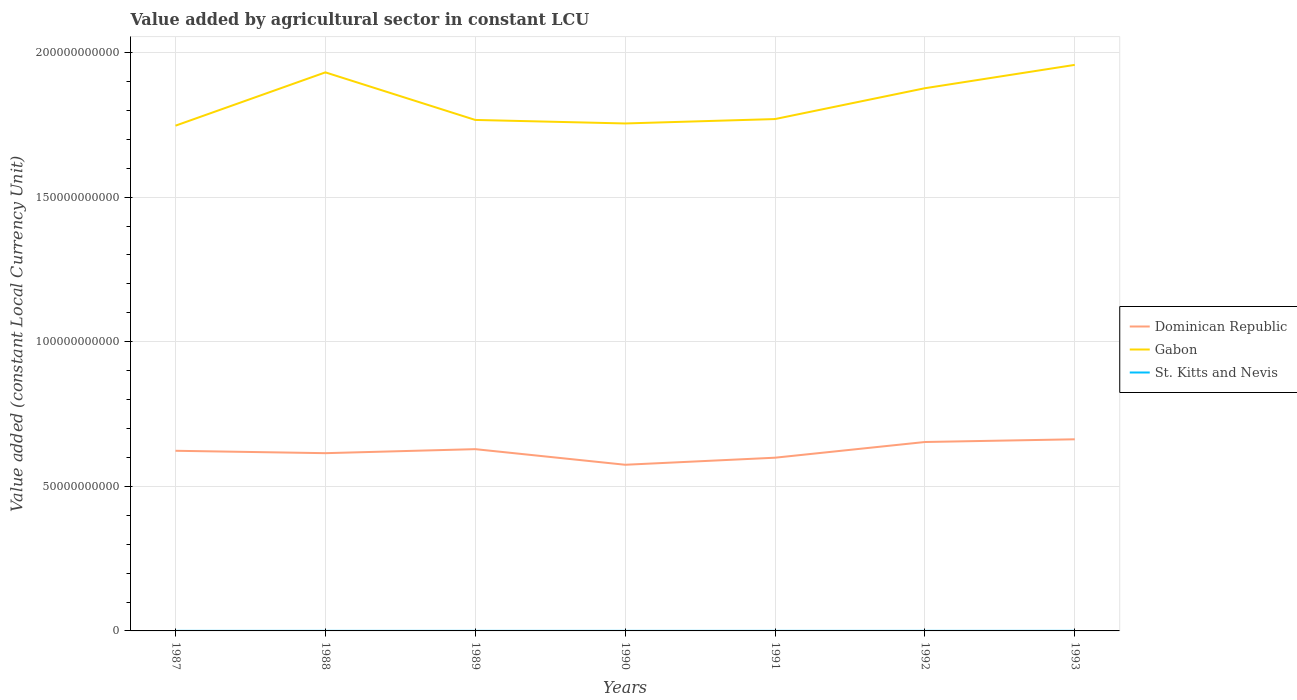Across all years, what is the maximum value added by agricultural sector in St. Kitts and Nevis?
Give a very brief answer. 2.16e+07. In which year was the value added by agricultural sector in Gabon maximum?
Make the answer very short. 1987. What is the total value added by agricultural sector in Gabon in the graph?
Ensure brevity in your answer.  -2.03e+1. What is the difference between the highest and the second highest value added by agricultural sector in Gabon?
Offer a very short reply. 2.10e+1. Is the value added by agricultural sector in Dominican Republic strictly greater than the value added by agricultural sector in Gabon over the years?
Provide a short and direct response. Yes. How many lines are there?
Offer a very short reply. 3. How many years are there in the graph?
Ensure brevity in your answer.  7. What is the difference between two consecutive major ticks on the Y-axis?
Offer a terse response. 5.00e+1. Does the graph contain any zero values?
Make the answer very short. No. Does the graph contain grids?
Your response must be concise. Yes. Where does the legend appear in the graph?
Provide a succinct answer. Center right. How many legend labels are there?
Offer a very short reply. 3. What is the title of the graph?
Offer a very short reply. Value added by agricultural sector in constant LCU. Does "Singapore" appear as one of the legend labels in the graph?
Your response must be concise. No. What is the label or title of the Y-axis?
Provide a succinct answer. Value added (constant Local Currency Unit). What is the Value added (constant Local Currency Unit) of Dominican Republic in 1987?
Your answer should be very brief. 6.23e+1. What is the Value added (constant Local Currency Unit) of Gabon in 1987?
Your answer should be compact. 1.75e+11. What is the Value added (constant Local Currency Unit) of St. Kitts and Nevis in 1987?
Provide a succinct answer. 2.18e+07. What is the Value added (constant Local Currency Unit) of Dominican Republic in 1988?
Make the answer very short. 6.15e+1. What is the Value added (constant Local Currency Unit) in Gabon in 1988?
Your answer should be very brief. 1.93e+11. What is the Value added (constant Local Currency Unit) in St. Kitts and Nevis in 1988?
Make the answer very short. 2.29e+07. What is the Value added (constant Local Currency Unit) in Dominican Republic in 1989?
Provide a succinct answer. 6.28e+1. What is the Value added (constant Local Currency Unit) in Gabon in 1989?
Your answer should be compact. 1.77e+11. What is the Value added (constant Local Currency Unit) of St. Kitts and Nevis in 1989?
Ensure brevity in your answer.  2.21e+07. What is the Value added (constant Local Currency Unit) of Dominican Republic in 1990?
Ensure brevity in your answer.  5.75e+1. What is the Value added (constant Local Currency Unit) of Gabon in 1990?
Your response must be concise. 1.75e+11. What is the Value added (constant Local Currency Unit) in St. Kitts and Nevis in 1990?
Give a very brief answer. 2.16e+07. What is the Value added (constant Local Currency Unit) in Dominican Republic in 1991?
Keep it short and to the point. 5.99e+1. What is the Value added (constant Local Currency Unit) in Gabon in 1991?
Your answer should be very brief. 1.77e+11. What is the Value added (constant Local Currency Unit) of St. Kitts and Nevis in 1991?
Keep it short and to the point. 2.28e+07. What is the Value added (constant Local Currency Unit) in Dominican Republic in 1992?
Your answer should be compact. 6.53e+1. What is the Value added (constant Local Currency Unit) of Gabon in 1992?
Your answer should be very brief. 1.88e+11. What is the Value added (constant Local Currency Unit) in St. Kitts and Nevis in 1992?
Offer a very short reply. 2.39e+07. What is the Value added (constant Local Currency Unit) of Dominican Republic in 1993?
Offer a very short reply. 6.63e+1. What is the Value added (constant Local Currency Unit) of Gabon in 1993?
Give a very brief answer. 1.96e+11. What is the Value added (constant Local Currency Unit) in St. Kitts and Nevis in 1993?
Your answer should be very brief. 2.47e+07. Across all years, what is the maximum Value added (constant Local Currency Unit) of Dominican Republic?
Offer a very short reply. 6.63e+1. Across all years, what is the maximum Value added (constant Local Currency Unit) of Gabon?
Ensure brevity in your answer.  1.96e+11. Across all years, what is the maximum Value added (constant Local Currency Unit) in St. Kitts and Nevis?
Provide a succinct answer. 2.47e+07. Across all years, what is the minimum Value added (constant Local Currency Unit) in Dominican Republic?
Keep it short and to the point. 5.75e+1. Across all years, what is the minimum Value added (constant Local Currency Unit) in Gabon?
Your answer should be compact. 1.75e+11. Across all years, what is the minimum Value added (constant Local Currency Unit) of St. Kitts and Nevis?
Make the answer very short. 2.16e+07. What is the total Value added (constant Local Currency Unit) in Dominican Republic in the graph?
Offer a terse response. 4.36e+11. What is the total Value added (constant Local Currency Unit) of Gabon in the graph?
Ensure brevity in your answer.  1.28e+12. What is the total Value added (constant Local Currency Unit) in St. Kitts and Nevis in the graph?
Provide a succinct answer. 1.60e+08. What is the difference between the Value added (constant Local Currency Unit) in Dominican Republic in 1987 and that in 1988?
Offer a very short reply. 8.25e+08. What is the difference between the Value added (constant Local Currency Unit) of Gabon in 1987 and that in 1988?
Offer a very short reply. -1.84e+1. What is the difference between the Value added (constant Local Currency Unit) in St. Kitts and Nevis in 1987 and that in 1988?
Offer a terse response. -1.15e+06. What is the difference between the Value added (constant Local Currency Unit) in Dominican Republic in 1987 and that in 1989?
Make the answer very short. -5.61e+08. What is the difference between the Value added (constant Local Currency Unit) of Gabon in 1987 and that in 1989?
Your answer should be very brief. -1.98e+09. What is the difference between the Value added (constant Local Currency Unit) in St. Kitts and Nevis in 1987 and that in 1989?
Provide a succinct answer. -3.05e+05. What is the difference between the Value added (constant Local Currency Unit) in Dominican Republic in 1987 and that in 1990?
Provide a short and direct response. 4.83e+09. What is the difference between the Value added (constant Local Currency Unit) in Gabon in 1987 and that in 1990?
Provide a short and direct response. -7.62e+08. What is the difference between the Value added (constant Local Currency Unit) in St. Kitts and Nevis in 1987 and that in 1990?
Provide a succinct answer. 2.00e+05. What is the difference between the Value added (constant Local Currency Unit) of Dominican Republic in 1987 and that in 1991?
Provide a short and direct response. 2.39e+09. What is the difference between the Value added (constant Local Currency Unit) in Gabon in 1987 and that in 1991?
Offer a very short reply. -2.28e+09. What is the difference between the Value added (constant Local Currency Unit) of St. Kitts and Nevis in 1987 and that in 1991?
Provide a succinct answer. -1.04e+06. What is the difference between the Value added (constant Local Currency Unit) in Dominican Republic in 1987 and that in 1992?
Your response must be concise. -3.03e+09. What is the difference between the Value added (constant Local Currency Unit) in Gabon in 1987 and that in 1992?
Your response must be concise. -1.29e+1. What is the difference between the Value added (constant Local Currency Unit) of St. Kitts and Nevis in 1987 and that in 1992?
Provide a succinct answer. -2.09e+06. What is the difference between the Value added (constant Local Currency Unit) of Dominican Republic in 1987 and that in 1993?
Provide a succinct answer. -3.97e+09. What is the difference between the Value added (constant Local Currency Unit) in Gabon in 1987 and that in 1993?
Your answer should be very brief. -2.10e+1. What is the difference between the Value added (constant Local Currency Unit) in St. Kitts and Nevis in 1987 and that in 1993?
Provide a succinct answer. -2.87e+06. What is the difference between the Value added (constant Local Currency Unit) in Dominican Republic in 1988 and that in 1989?
Keep it short and to the point. -1.39e+09. What is the difference between the Value added (constant Local Currency Unit) in Gabon in 1988 and that in 1989?
Your answer should be compact. 1.65e+1. What is the difference between the Value added (constant Local Currency Unit) in St. Kitts and Nevis in 1988 and that in 1989?
Give a very brief answer. 8.42e+05. What is the difference between the Value added (constant Local Currency Unit) of Dominican Republic in 1988 and that in 1990?
Provide a succinct answer. 4.01e+09. What is the difference between the Value added (constant Local Currency Unit) in Gabon in 1988 and that in 1990?
Your answer should be very brief. 1.77e+1. What is the difference between the Value added (constant Local Currency Unit) of St. Kitts and Nevis in 1988 and that in 1990?
Offer a terse response. 1.35e+06. What is the difference between the Value added (constant Local Currency Unit) of Dominican Republic in 1988 and that in 1991?
Offer a very short reply. 1.57e+09. What is the difference between the Value added (constant Local Currency Unit) in Gabon in 1988 and that in 1991?
Give a very brief answer. 1.61e+1. What is the difference between the Value added (constant Local Currency Unit) of St. Kitts and Nevis in 1988 and that in 1991?
Offer a terse response. 1.11e+05. What is the difference between the Value added (constant Local Currency Unit) of Dominican Republic in 1988 and that in 1992?
Keep it short and to the point. -3.86e+09. What is the difference between the Value added (constant Local Currency Unit) in Gabon in 1988 and that in 1992?
Give a very brief answer. 5.48e+09. What is the difference between the Value added (constant Local Currency Unit) of St. Kitts and Nevis in 1988 and that in 1992?
Make the answer very short. -9.39e+05. What is the difference between the Value added (constant Local Currency Unit) of Dominican Republic in 1988 and that in 1993?
Your answer should be very brief. -4.80e+09. What is the difference between the Value added (constant Local Currency Unit) of Gabon in 1988 and that in 1993?
Your response must be concise. -2.59e+09. What is the difference between the Value added (constant Local Currency Unit) in St. Kitts and Nevis in 1988 and that in 1993?
Make the answer very short. -1.72e+06. What is the difference between the Value added (constant Local Currency Unit) in Dominican Republic in 1989 and that in 1990?
Provide a short and direct response. 5.39e+09. What is the difference between the Value added (constant Local Currency Unit) in Gabon in 1989 and that in 1990?
Ensure brevity in your answer.  1.22e+09. What is the difference between the Value added (constant Local Currency Unit) of St. Kitts and Nevis in 1989 and that in 1990?
Your answer should be very brief. 5.05e+05. What is the difference between the Value added (constant Local Currency Unit) in Dominican Republic in 1989 and that in 1991?
Offer a very short reply. 2.96e+09. What is the difference between the Value added (constant Local Currency Unit) of Gabon in 1989 and that in 1991?
Keep it short and to the point. -3.05e+08. What is the difference between the Value added (constant Local Currency Unit) in St. Kitts and Nevis in 1989 and that in 1991?
Offer a terse response. -7.32e+05. What is the difference between the Value added (constant Local Currency Unit) in Dominican Republic in 1989 and that in 1992?
Your answer should be compact. -2.47e+09. What is the difference between the Value added (constant Local Currency Unit) in Gabon in 1989 and that in 1992?
Your answer should be very brief. -1.10e+1. What is the difference between the Value added (constant Local Currency Unit) in St. Kitts and Nevis in 1989 and that in 1992?
Provide a short and direct response. -1.78e+06. What is the difference between the Value added (constant Local Currency Unit) of Dominican Republic in 1989 and that in 1993?
Your answer should be very brief. -3.41e+09. What is the difference between the Value added (constant Local Currency Unit) of Gabon in 1989 and that in 1993?
Your answer should be very brief. -1.90e+1. What is the difference between the Value added (constant Local Currency Unit) in St. Kitts and Nevis in 1989 and that in 1993?
Keep it short and to the point. -2.57e+06. What is the difference between the Value added (constant Local Currency Unit) in Dominican Republic in 1990 and that in 1991?
Give a very brief answer. -2.44e+09. What is the difference between the Value added (constant Local Currency Unit) of Gabon in 1990 and that in 1991?
Provide a succinct answer. -1.52e+09. What is the difference between the Value added (constant Local Currency Unit) in St. Kitts and Nevis in 1990 and that in 1991?
Offer a terse response. -1.24e+06. What is the difference between the Value added (constant Local Currency Unit) in Dominican Republic in 1990 and that in 1992?
Provide a succinct answer. -7.87e+09. What is the difference between the Value added (constant Local Currency Unit) in Gabon in 1990 and that in 1992?
Provide a short and direct response. -1.22e+1. What is the difference between the Value added (constant Local Currency Unit) in St. Kitts and Nevis in 1990 and that in 1992?
Make the answer very short. -2.29e+06. What is the difference between the Value added (constant Local Currency Unit) in Dominican Republic in 1990 and that in 1993?
Make the answer very short. -8.80e+09. What is the difference between the Value added (constant Local Currency Unit) of Gabon in 1990 and that in 1993?
Keep it short and to the point. -2.03e+1. What is the difference between the Value added (constant Local Currency Unit) in St. Kitts and Nevis in 1990 and that in 1993?
Give a very brief answer. -3.07e+06. What is the difference between the Value added (constant Local Currency Unit) of Dominican Republic in 1991 and that in 1992?
Keep it short and to the point. -5.43e+09. What is the difference between the Value added (constant Local Currency Unit) in Gabon in 1991 and that in 1992?
Your answer should be very brief. -1.07e+1. What is the difference between the Value added (constant Local Currency Unit) in St. Kitts and Nevis in 1991 and that in 1992?
Your response must be concise. -1.05e+06. What is the difference between the Value added (constant Local Currency Unit) of Dominican Republic in 1991 and that in 1993?
Offer a very short reply. -6.37e+09. What is the difference between the Value added (constant Local Currency Unit) of Gabon in 1991 and that in 1993?
Your answer should be very brief. -1.87e+1. What is the difference between the Value added (constant Local Currency Unit) of St. Kitts and Nevis in 1991 and that in 1993?
Offer a terse response. -1.83e+06. What is the difference between the Value added (constant Local Currency Unit) in Dominican Republic in 1992 and that in 1993?
Your answer should be very brief. -9.37e+08. What is the difference between the Value added (constant Local Currency Unit) in Gabon in 1992 and that in 1993?
Your response must be concise. -8.07e+09. What is the difference between the Value added (constant Local Currency Unit) of St. Kitts and Nevis in 1992 and that in 1993?
Your response must be concise. -7.85e+05. What is the difference between the Value added (constant Local Currency Unit) in Dominican Republic in 1987 and the Value added (constant Local Currency Unit) in Gabon in 1988?
Ensure brevity in your answer.  -1.31e+11. What is the difference between the Value added (constant Local Currency Unit) in Dominican Republic in 1987 and the Value added (constant Local Currency Unit) in St. Kitts and Nevis in 1988?
Your response must be concise. 6.23e+1. What is the difference between the Value added (constant Local Currency Unit) of Gabon in 1987 and the Value added (constant Local Currency Unit) of St. Kitts and Nevis in 1988?
Your answer should be compact. 1.75e+11. What is the difference between the Value added (constant Local Currency Unit) of Dominican Republic in 1987 and the Value added (constant Local Currency Unit) of Gabon in 1989?
Keep it short and to the point. -1.14e+11. What is the difference between the Value added (constant Local Currency Unit) of Dominican Republic in 1987 and the Value added (constant Local Currency Unit) of St. Kitts and Nevis in 1989?
Your response must be concise. 6.23e+1. What is the difference between the Value added (constant Local Currency Unit) of Gabon in 1987 and the Value added (constant Local Currency Unit) of St. Kitts and Nevis in 1989?
Your response must be concise. 1.75e+11. What is the difference between the Value added (constant Local Currency Unit) of Dominican Republic in 1987 and the Value added (constant Local Currency Unit) of Gabon in 1990?
Provide a succinct answer. -1.13e+11. What is the difference between the Value added (constant Local Currency Unit) of Dominican Republic in 1987 and the Value added (constant Local Currency Unit) of St. Kitts and Nevis in 1990?
Your answer should be very brief. 6.23e+1. What is the difference between the Value added (constant Local Currency Unit) in Gabon in 1987 and the Value added (constant Local Currency Unit) in St. Kitts and Nevis in 1990?
Keep it short and to the point. 1.75e+11. What is the difference between the Value added (constant Local Currency Unit) of Dominican Republic in 1987 and the Value added (constant Local Currency Unit) of Gabon in 1991?
Offer a terse response. -1.15e+11. What is the difference between the Value added (constant Local Currency Unit) in Dominican Republic in 1987 and the Value added (constant Local Currency Unit) in St. Kitts and Nevis in 1991?
Provide a short and direct response. 6.23e+1. What is the difference between the Value added (constant Local Currency Unit) in Gabon in 1987 and the Value added (constant Local Currency Unit) in St. Kitts and Nevis in 1991?
Your answer should be compact. 1.75e+11. What is the difference between the Value added (constant Local Currency Unit) in Dominican Republic in 1987 and the Value added (constant Local Currency Unit) in Gabon in 1992?
Make the answer very short. -1.25e+11. What is the difference between the Value added (constant Local Currency Unit) of Dominican Republic in 1987 and the Value added (constant Local Currency Unit) of St. Kitts and Nevis in 1992?
Keep it short and to the point. 6.23e+1. What is the difference between the Value added (constant Local Currency Unit) in Gabon in 1987 and the Value added (constant Local Currency Unit) in St. Kitts and Nevis in 1992?
Offer a very short reply. 1.75e+11. What is the difference between the Value added (constant Local Currency Unit) in Dominican Republic in 1987 and the Value added (constant Local Currency Unit) in Gabon in 1993?
Offer a terse response. -1.33e+11. What is the difference between the Value added (constant Local Currency Unit) of Dominican Republic in 1987 and the Value added (constant Local Currency Unit) of St. Kitts and Nevis in 1993?
Give a very brief answer. 6.23e+1. What is the difference between the Value added (constant Local Currency Unit) in Gabon in 1987 and the Value added (constant Local Currency Unit) in St. Kitts and Nevis in 1993?
Offer a very short reply. 1.75e+11. What is the difference between the Value added (constant Local Currency Unit) of Dominican Republic in 1988 and the Value added (constant Local Currency Unit) of Gabon in 1989?
Provide a short and direct response. -1.15e+11. What is the difference between the Value added (constant Local Currency Unit) of Dominican Republic in 1988 and the Value added (constant Local Currency Unit) of St. Kitts and Nevis in 1989?
Offer a very short reply. 6.14e+1. What is the difference between the Value added (constant Local Currency Unit) of Gabon in 1988 and the Value added (constant Local Currency Unit) of St. Kitts and Nevis in 1989?
Your answer should be compact. 1.93e+11. What is the difference between the Value added (constant Local Currency Unit) of Dominican Republic in 1988 and the Value added (constant Local Currency Unit) of Gabon in 1990?
Offer a terse response. -1.14e+11. What is the difference between the Value added (constant Local Currency Unit) of Dominican Republic in 1988 and the Value added (constant Local Currency Unit) of St. Kitts and Nevis in 1990?
Give a very brief answer. 6.14e+1. What is the difference between the Value added (constant Local Currency Unit) in Gabon in 1988 and the Value added (constant Local Currency Unit) in St. Kitts and Nevis in 1990?
Offer a terse response. 1.93e+11. What is the difference between the Value added (constant Local Currency Unit) of Dominican Republic in 1988 and the Value added (constant Local Currency Unit) of Gabon in 1991?
Provide a short and direct response. -1.16e+11. What is the difference between the Value added (constant Local Currency Unit) in Dominican Republic in 1988 and the Value added (constant Local Currency Unit) in St. Kitts and Nevis in 1991?
Provide a short and direct response. 6.14e+1. What is the difference between the Value added (constant Local Currency Unit) of Gabon in 1988 and the Value added (constant Local Currency Unit) of St. Kitts and Nevis in 1991?
Your answer should be compact. 1.93e+11. What is the difference between the Value added (constant Local Currency Unit) of Dominican Republic in 1988 and the Value added (constant Local Currency Unit) of Gabon in 1992?
Give a very brief answer. -1.26e+11. What is the difference between the Value added (constant Local Currency Unit) in Dominican Republic in 1988 and the Value added (constant Local Currency Unit) in St. Kitts and Nevis in 1992?
Ensure brevity in your answer.  6.14e+1. What is the difference between the Value added (constant Local Currency Unit) in Gabon in 1988 and the Value added (constant Local Currency Unit) in St. Kitts and Nevis in 1992?
Give a very brief answer. 1.93e+11. What is the difference between the Value added (constant Local Currency Unit) of Dominican Republic in 1988 and the Value added (constant Local Currency Unit) of Gabon in 1993?
Provide a succinct answer. -1.34e+11. What is the difference between the Value added (constant Local Currency Unit) in Dominican Republic in 1988 and the Value added (constant Local Currency Unit) in St. Kitts and Nevis in 1993?
Provide a short and direct response. 6.14e+1. What is the difference between the Value added (constant Local Currency Unit) in Gabon in 1988 and the Value added (constant Local Currency Unit) in St. Kitts and Nevis in 1993?
Ensure brevity in your answer.  1.93e+11. What is the difference between the Value added (constant Local Currency Unit) in Dominican Republic in 1989 and the Value added (constant Local Currency Unit) in Gabon in 1990?
Offer a terse response. -1.13e+11. What is the difference between the Value added (constant Local Currency Unit) in Dominican Republic in 1989 and the Value added (constant Local Currency Unit) in St. Kitts and Nevis in 1990?
Your answer should be compact. 6.28e+1. What is the difference between the Value added (constant Local Currency Unit) in Gabon in 1989 and the Value added (constant Local Currency Unit) in St. Kitts and Nevis in 1990?
Offer a very short reply. 1.77e+11. What is the difference between the Value added (constant Local Currency Unit) of Dominican Republic in 1989 and the Value added (constant Local Currency Unit) of Gabon in 1991?
Ensure brevity in your answer.  -1.14e+11. What is the difference between the Value added (constant Local Currency Unit) in Dominican Republic in 1989 and the Value added (constant Local Currency Unit) in St. Kitts and Nevis in 1991?
Your response must be concise. 6.28e+1. What is the difference between the Value added (constant Local Currency Unit) in Gabon in 1989 and the Value added (constant Local Currency Unit) in St. Kitts and Nevis in 1991?
Your answer should be compact. 1.77e+11. What is the difference between the Value added (constant Local Currency Unit) of Dominican Republic in 1989 and the Value added (constant Local Currency Unit) of Gabon in 1992?
Provide a short and direct response. -1.25e+11. What is the difference between the Value added (constant Local Currency Unit) in Dominican Republic in 1989 and the Value added (constant Local Currency Unit) in St. Kitts and Nevis in 1992?
Offer a terse response. 6.28e+1. What is the difference between the Value added (constant Local Currency Unit) of Gabon in 1989 and the Value added (constant Local Currency Unit) of St. Kitts and Nevis in 1992?
Provide a short and direct response. 1.77e+11. What is the difference between the Value added (constant Local Currency Unit) in Dominican Republic in 1989 and the Value added (constant Local Currency Unit) in Gabon in 1993?
Your answer should be very brief. -1.33e+11. What is the difference between the Value added (constant Local Currency Unit) in Dominican Republic in 1989 and the Value added (constant Local Currency Unit) in St. Kitts and Nevis in 1993?
Your response must be concise. 6.28e+1. What is the difference between the Value added (constant Local Currency Unit) in Gabon in 1989 and the Value added (constant Local Currency Unit) in St. Kitts and Nevis in 1993?
Make the answer very short. 1.77e+11. What is the difference between the Value added (constant Local Currency Unit) of Dominican Republic in 1990 and the Value added (constant Local Currency Unit) of Gabon in 1991?
Keep it short and to the point. -1.20e+11. What is the difference between the Value added (constant Local Currency Unit) of Dominican Republic in 1990 and the Value added (constant Local Currency Unit) of St. Kitts and Nevis in 1991?
Offer a very short reply. 5.74e+1. What is the difference between the Value added (constant Local Currency Unit) of Gabon in 1990 and the Value added (constant Local Currency Unit) of St. Kitts and Nevis in 1991?
Your answer should be very brief. 1.75e+11. What is the difference between the Value added (constant Local Currency Unit) in Dominican Republic in 1990 and the Value added (constant Local Currency Unit) in Gabon in 1992?
Ensure brevity in your answer.  -1.30e+11. What is the difference between the Value added (constant Local Currency Unit) in Dominican Republic in 1990 and the Value added (constant Local Currency Unit) in St. Kitts and Nevis in 1992?
Your answer should be very brief. 5.74e+1. What is the difference between the Value added (constant Local Currency Unit) of Gabon in 1990 and the Value added (constant Local Currency Unit) of St. Kitts and Nevis in 1992?
Keep it short and to the point. 1.75e+11. What is the difference between the Value added (constant Local Currency Unit) in Dominican Republic in 1990 and the Value added (constant Local Currency Unit) in Gabon in 1993?
Make the answer very short. -1.38e+11. What is the difference between the Value added (constant Local Currency Unit) in Dominican Republic in 1990 and the Value added (constant Local Currency Unit) in St. Kitts and Nevis in 1993?
Provide a short and direct response. 5.74e+1. What is the difference between the Value added (constant Local Currency Unit) of Gabon in 1990 and the Value added (constant Local Currency Unit) of St. Kitts and Nevis in 1993?
Make the answer very short. 1.75e+11. What is the difference between the Value added (constant Local Currency Unit) of Dominican Republic in 1991 and the Value added (constant Local Currency Unit) of Gabon in 1992?
Give a very brief answer. -1.28e+11. What is the difference between the Value added (constant Local Currency Unit) of Dominican Republic in 1991 and the Value added (constant Local Currency Unit) of St. Kitts and Nevis in 1992?
Offer a very short reply. 5.99e+1. What is the difference between the Value added (constant Local Currency Unit) in Gabon in 1991 and the Value added (constant Local Currency Unit) in St. Kitts and Nevis in 1992?
Your response must be concise. 1.77e+11. What is the difference between the Value added (constant Local Currency Unit) in Dominican Republic in 1991 and the Value added (constant Local Currency Unit) in Gabon in 1993?
Your answer should be compact. -1.36e+11. What is the difference between the Value added (constant Local Currency Unit) of Dominican Republic in 1991 and the Value added (constant Local Currency Unit) of St. Kitts and Nevis in 1993?
Your answer should be compact. 5.99e+1. What is the difference between the Value added (constant Local Currency Unit) of Gabon in 1991 and the Value added (constant Local Currency Unit) of St. Kitts and Nevis in 1993?
Your response must be concise. 1.77e+11. What is the difference between the Value added (constant Local Currency Unit) of Dominican Republic in 1992 and the Value added (constant Local Currency Unit) of Gabon in 1993?
Make the answer very short. -1.30e+11. What is the difference between the Value added (constant Local Currency Unit) of Dominican Republic in 1992 and the Value added (constant Local Currency Unit) of St. Kitts and Nevis in 1993?
Offer a terse response. 6.53e+1. What is the difference between the Value added (constant Local Currency Unit) in Gabon in 1992 and the Value added (constant Local Currency Unit) in St. Kitts and Nevis in 1993?
Provide a succinct answer. 1.88e+11. What is the average Value added (constant Local Currency Unit) of Dominican Republic per year?
Ensure brevity in your answer.  6.22e+1. What is the average Value added (constant Local Currency Unit) of Gabon per year?
Your answer should be compact. 1.83e+11. What is the average Value added (constant Local Currency Unit) in St. Kitts and Nevis per year?
Give a very brief answer. 2.28e+07. In the year 1987, what is the difference between the Value added (constant Local Currency Unit) of Dominican Republic and Value added (constant Local Currency Unit) of Gabon?
Offer a very short reply. -1.12e+11. In the year 1987, what is the difference between the Value added (constant Local Currency Unit) of Dominican Republic and Value added (constant Local Currency Unit) of St. Kitts and Nevis?
Provide a succinct answer. 6.23e+1. In the year 1987, what is the difference between the Value added (constant Local Currency Unit) of Gabon and Value added (constant Local Currency Unit) of St. Kitts and Nevis?
Your answer should be compact. 1.75e+11. In the year 1988, what is the difference between the Value added (constant Local Currency Unit) in Dominican Republic and Value added (constant Local Currency Unit) in Gabon?
Give a very brief answer. -1.32e+11. In the year 1988, what is the difference between the Value added (constant Local Currency Unit) of Dominican Republic and Value added (constant Local Currency Unit) of St. Kitts and Nevis?
Your answer should be compact. 6.14e+1. In the year 1988, what is the difference between the Value added (constant Local Currency Unit) in Gabon and Value added (constant Local Currency Unit) in St. Kitts and Nevis?
Give a very brief answer. 1.93e+11. In the year 1989, what is the difference between the Value added (constant Local Currency Unit) in Dominican Republic and Value added (constant Local Currency Unit) in Gabon?
Ensure brevity in your answer.  -1.14e+11. In the year 1989, what is the difference between the Value added (constant Local Currency Unit) in Dominican Republic and Value added (constant Local Currency Unit) in St. Kitts and Nevis?
Your response must be concise. 6.28e+1. In the year 1989, what is the difference between the Value added (constant Local Currency Unit) of Gabon and Value added (constant Local Currency Unit) of St. Kitts and Nevis?
Give a very brief answer. 1.77e+11. In the year 1990, what is the difference between the Value added (constant Local Currency Unit) of Dominican Republic and Value added (constant Local Currency Unit) of Gabon?
Make the answer very short. -1.18e+11. In the year 1990, what is the difference between the Value added (constant Local Currency Unit) of Dominican Republic and Value added (constant Local Currency Unit) of St. Kitts and Nevis?
Your answer should be very brief. 5.74e+1. In the year 1990, what is the difference between the Value added (constant Local Currency Unit) in Gabon and Value added (constant Local Currency Unit) in St. Kitts and Nevis?
Make the answer very short. 1.75e+11. In the year 1991, what is the difference between the Value added (constant Local Currency Unit) of Dominican Republic and Value added (constant Local Currency Unit) of Gabon?
Provide a succinct answer. -1.17e+11. In the year 1991, what is the difference between the Value added (constant Local Currency Unit) in Dominican Republic and Value added (constant Local Currency Unit) in St. Kitts and Nevis?
Give a very brief answer. 5.99e+1. In the year 1991, what is the difference between the Value added (constant Local Currency Unit) of Gabon and Value added (constant Local Currency Unit) of St. Kitts and Nevis?
Your answer should be compact. 1.77e+11. In the year 1992, what is the difference between the Value added (constant Local Currency Unit) of Dominican Republic and Value added (constant Local Currency Unit) of Gabon?
Your answer should be compact. -1.22e+11. In the year 1992, what is the difference between the Value added (constant Local Currency Unit) of Dominican Republic and Value added (constant Local Currency Unit) of St. Kitts and Nevis?
Make the answer very short. 6.53e+1. In the year 1992, what is the difference between the Value added (constant Local Currency Unit) of Gabon and Value added (constant Local Currency Unit) of St. Kitts and Nevis?
Your response must be concise. 1.88e+11. In the year 1993, what is the difference between the Value added (constant Local Currency Unit) of Dominican Republic and Value added (constant Local Currency Unit) of Gabon?
Your answer should be compact. -1.29e+11. In the year 1993, what is the difference between the Value added (constant Local Currency Unit) of Dominican Republic and Value added (constant Local Currency Unit) of St. Kitts and Nevis?
Offer a very short reply. 6.62e+1. In the year 1993, what is the difference between the Value added (constant Local Currency Unit) in Gabon and Value added (constant Local Currency Unit) in St. Kitts and Nevis?
Your answer should be compact. 1.96e+11. What is the ratio of the Value added (constant Local Currency Unit) of Dominican Republic in 1987 to that in 1988?
Your answer should be very brief. 1.01. What is the ratio of the Value added (constant Local Currency Unit) in Gabon in 1987 to that in 1988?
Give a very brief answer. 0.9. What is the ratio of the Value added (constant Local Currency Unit) of St. Kitts and Nevis in 1987 to that in 1988?
Provide a succinct answer. 0.95. What is the ratio of the Value added (constant Local Currency Unit) of Dominican Republic in 1987 to that in 1989?
Provide a succinct answer. 0.99. What is the ratio of the Value added (constant Local Currency Unit) of St. Kitts and Nevis in 1987 to that in 1989?
Offer a very short reply. 0.99. What is the ratio of the Value added (constant Local Currency Unit) of Dominican Republic in 1987 to that in 1990?
Ensure brevity in your answer.  1.08. What is the ratio of the Value added (constant Local Currency Unit) of St. Kitts and Nevis in 1987 to that in 1990?
Give a very brief answer. 1.01. What is the ratio of the Value added (constant Local Currency Unit) in Dominican Republic in 1987 to that in 1991?
Give a very brief answer. 1.04. What is the ratio of the Value added (constant Local Currency Unit) of Gabon in 1987 to that in 1991?
Ensure brevity in your answer.  0.99. What is the ratio of the Value added (constant Local Currency Unit) in St. Kitts and Nevis in 1987 to that in 1991?
Keep it short and to the point. 0.95. What is the ratio of the Value added (constant Local Currency Unit) of Dominican Republic in 1987 to that in 1992?
Offer a very short reply. 0.95. What is the ratio of the Value added (constant Local Currency Unit) of St. Kitts and Nevis in 1987 to that in 1992?
Ensure brevity in your answer.  0.91. What is the ratio of the Value added (constant Local Currency Unit) in Dominican Republic in 1987 to that in 1993?
Keep it short and to the point. 0.94. What is the ratio of the Value added (constant Local Currency Unit) of Gabon in 1987 to that in 1993?
Your answer should be compact. 0.89. What is the ratio of the Value added (constant Local Currency Unit) of St. Kitts and Nevis in 1987 to that in 1993?
Your response must be concise. 0.88. What is the ratio of the Value added (constant Local Currency Unit) in Dominican Republic in 1988 to that in 1989?
Make the answer very short. 0.98. What is the ratio of the Value added (constant Local Currency Unit) of Gabon in 1988 to that in 1989?
Give a very brief answer. 1.09. What is the ratio of the Value added (constant Local Currency Unit) of St. Kitts and Nevis in 1988 to that in 1989?
Offer a very short reply. 1.04. What is the ratio of the Value added (constant Local Currency Unit) of Dominican Republic in 1988 to that in 1990?
Offer a terse response. 1.07. What is the ratio of the Value added (constant Local Currency Unit) of Gabon in 1988 to that in 1990?
Offer a terse response. 1.1. What is the ratio of the Value added (constant Local Currency Unit) in St. Kitts and Nevis in 1988 to that in 1990?
Offer a terse response. 1.06. What is the ratio of the Value added (constant Local Currency Unit) in Dominican Republic in 1988 to that in 1991?
Offer a very short reply. 1.03. What is the ratio of the Value added (constant Local Currency Unit) in Gabon in 1988 to that in 1991?
Keep it short and to the point. 1.09. What is the ratio of the Value added (constant Local Currency Unit) in St. Kitts and Nevis in 1988 to that in 1991?
Offer a terse response. 1. What is the ratio of the Value added (constant Local Currency Unit) of Dominican Republic in 1988 to that in 1992?
Your answer should be compact. 0.94. What is the ratio of the Value added (constant Local Currency Unit) of Gabon in 1988 to that in 1992?
Provide a succinct answer. 1.03. What is the ratio of the Value added (constant Local Currency Unit) in St. Kitts and Nevis in 1988 to that in 1992?
Make the answer very short. 0.96. What is the ratio of the Value added (constant Local Currency Unit) in Dominican Republic in 1988 to that in 1993?
Ensure brevity in your answer.  0.93. What is the ratio of the Value added (constant Local Currency Unit) of St. Kitts and Nevis in 1988 to that in 1993?
Provide a succinct answer. 0.93. What is the ratio of the Value added (constant Local Currency Unit) in Dominican Republic in 1989 to that in 1990?
Keep it short and to the point. 1.09. What is the ratio of the Value added (constant Local Currency Unit) of St. Kitts and Nevis in 1989 to that in 1990?
Your response must be concise. 1.02. What is the ratio of the Value added (constant Local Currency Unit) of Dominican Republic in 1989 to that in 1991?
Keep it short and to the point. 1.05. What is the ratio of the Value added (constant Local Currency Unit) in Gabon in 1989 to that in 1991?
Your answer should be compact. 1. What is the ratio of the Value added (constant Local Currency Unit) in St. Kitts and Nevis in 1989 to that in 1991?
Your answer should be compact. 0.97. What is the ratio of the Value added (constant Local Currency Unit) of Dominican Republic in 1989 to that in 1992?
Your answer should be very brief. 0.96. What is the ratio of the Value added (constant Local Currency Unit) in Gabon in 1989 to that in 1992?
Give a very brief answer. 0.94. What is the ratio of the Value added (constant Local Currency Unit) in St. Kitts and Nevis in 1989 to that in 1992?
Make the answer very short. 0.93. What is the ratio of the Value added (constant Local Currency Unit) in Dominican Republic in 1989 to that in 1993?
Your response must be concise. 0.95. What is the ratio of the Value added (constant Local Currency Unit) of Gabon in 1989 to that in 1993?
Keep it short and to the point. 0.9. What is the ratio of the Value added (constant Local Currency Unit) in St. Kitts and Nevis in 1989 to that in 1993?
Your answer should be very brief. 0.9. What is the ratio of the Value added (constant Local Currency Unit) of Dominican Republic in 1990 to that in 1991?
Provide a short and direct response. 0.96. What is the ratio of the Value added (constant Local Currency Unit) of Gabon in 1990 to that in 1991?
Give a very brief answer. 0.99. What is the ratio of the Value added (constant Local Currency Unit) of St. Kitts and Nevis in 1990 to that in 1991?
Your answer should be compact. 0.95. What is the ratio of the Value added (constant Local Currency Unit) in Dominican Republic in 1990 to that in 1992?
Your answer should be compact. 0.88. What is the ratio of the Value added (constant Local Currency Unit) in Gabon in 1990 to that in 1992?
Give a very brief answer. 0.94. What is the ratio of the Value added (constant Local Currency Unit) in St. Kitts and Nevis in 1990 to that in 1992?
Provide a succinct answer. 0.9. What is the ratio of the Value added (constant Local Currency Unit) in Dominican Republic in 1990 to that in 1993?
Offer a very short reply. 0.87. What is the ratio of the Value added (constant Local Currency Unit) of Gabon in 1990 to that in 1993?
Offer a terse response. 0.9. What is the ratio of the Value added (constant Local Currency Unit) of St. Kitts and Nevis in 1990 to that in 1993?
Offer a very short reply. 0.88. What is the ratio of the Value added (constant Local Currency Unit) in Dominican Republic in 1991 to that in 1992?
Offer a terse response. 0.92. What is the ratio of the Value added (constant Local Currency Unit) in Gabon in 1991 to that in 1992?
Give a very brief answer. 0.94. What is the ratio of the Value added (constant Local Currency Unit) of St. Kitts and Nevis in 1991 to that in 1992?
Provide a succinct answer. 0.96. What is the ratio of the Value added (constant Local Currency Unit) of Dominican Republic in 1991 to that in 1993?
Your answer should be compact. 0.9. What is the ratio of the Value added (constant Local Currency Unit) in Gabon in 1991 to that in 1993?
Offer a very short reply. 0.9. What is the ratio of the Value added (constant Local Currency Unit) in St. Kitts and Nevis in 1991 to that in 1993?
Your response must be concise. 0.93. What is the ratio of the Value added (constant Local Currency Unit) in Dominican Republic in 1992 to that in 1993?
Ensure brevity in your answer.  0.99. What is the ratio of the Value added (constant Local Currency Unit) of Gabon in 1992 to that in 1993?
Provide a succinct answer. 0.96. What is the ratio of the Value added (constant Local Currency Unit) of St. Kitts and Nevis in 1992 to that in 1993?
Offer a very short reply. 0.97. What is the difference between the highest and the second highest Value added (constant Local Currency Unit) in Dominican Republic?
Provide a short and direct response. 9.37e+08. What is the difference between the highest and the second highest Value added (constant Local Currency Unit) in Gabon?
Your answer should be compact. 2.59e+09. What is the difference between the highest and the second highest Value added (constant Local Currency Unit) of St. Kitts and Nevis?
Give a very brief answer. 7.85e+05. What is the difference between the highest and the lowest Value added (constant Local Currency Unit) in Dominican Republic?
Your response must be concise. 8.80e+09. What is the difference between the highest and the lowest Value added (constant Local Currency Unit) in Gabon?
Your response must be concise. 2.10e+1. What is the difference between the highest and the lowest Value added (constant Local Currency Unit) in St. Kitts and Nevis?
Give a very brief answer. 3.07e+06. 